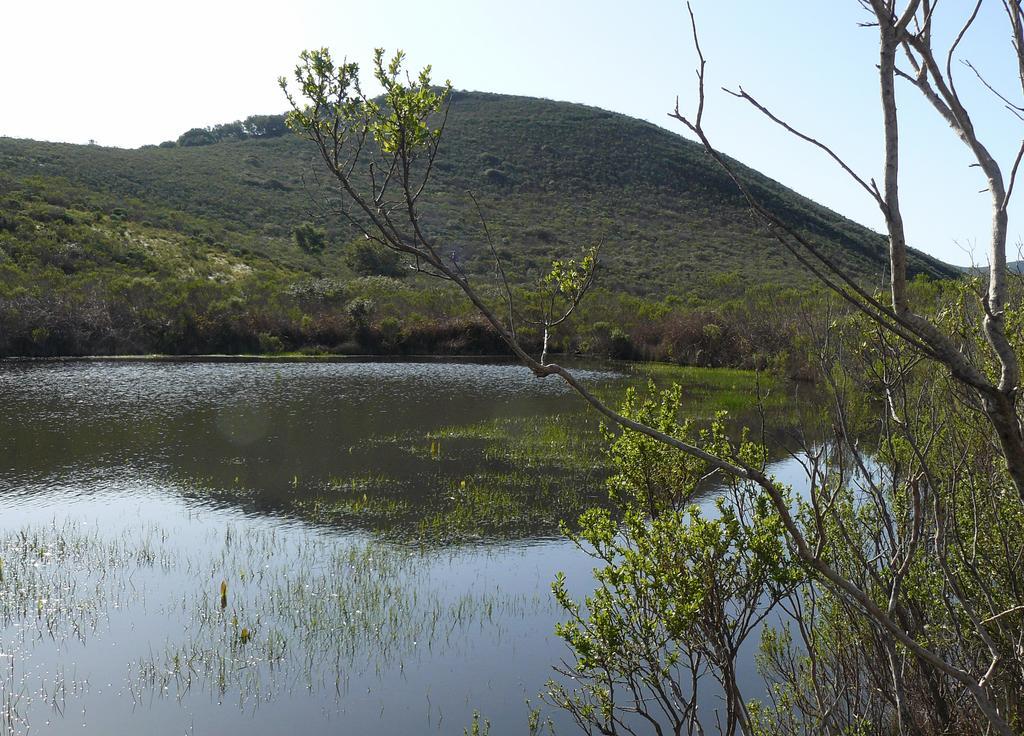Please provide a concise description of this image. In this image there is the sky towards the top of the image, there is a mountain, there are trees on the mountain, there is water towards the bottom of the image, there are plants in the water, there is a tree towards the right of the image. 